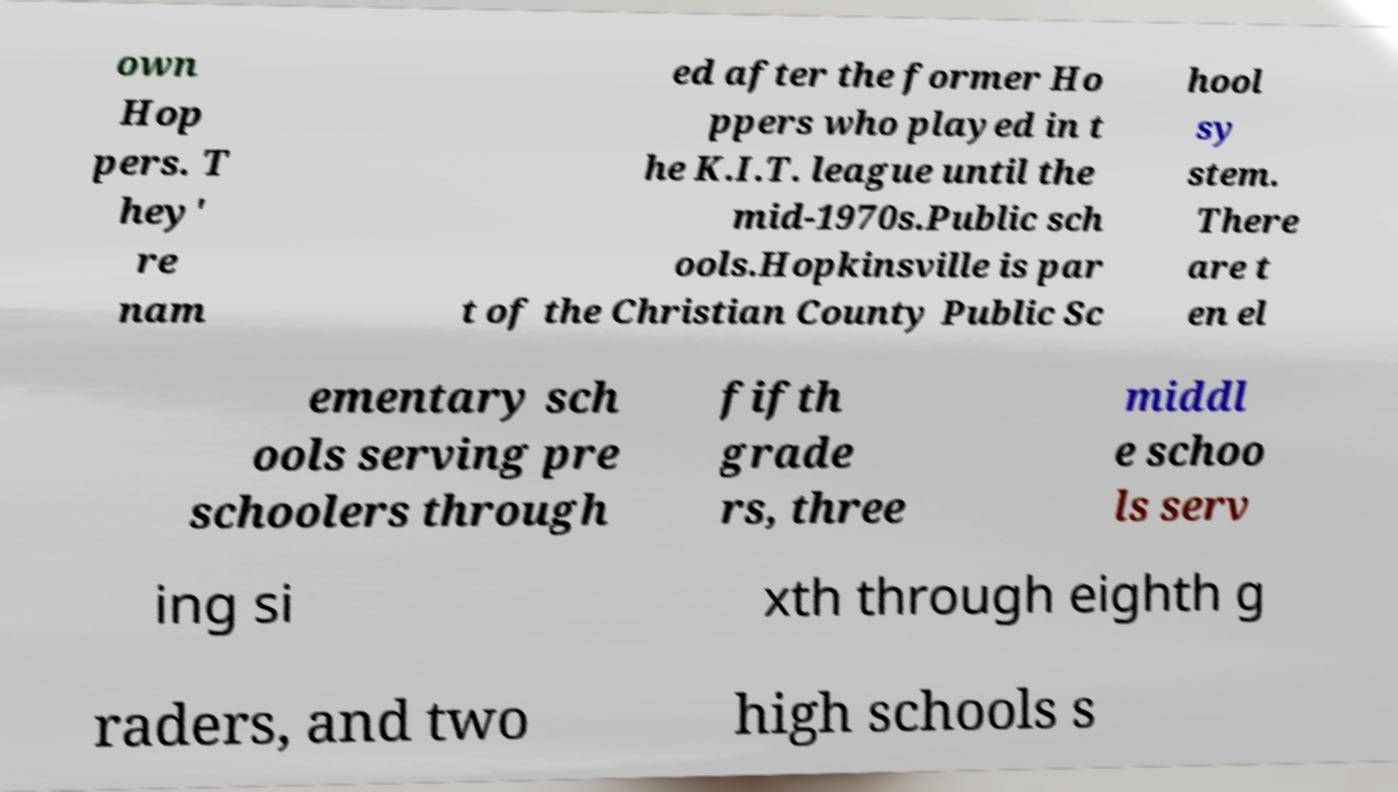Please read and relay the text visible in this image. What does it say? own Hop pers. T hey' re nam ed after the former Ho ppers who played in t he K.I.T. league until the mid-1970s.Public sch ools.Hopkinsville is par t of the Christian County Public Sc hool sy stem. There are t en el ementary sch ools serving pre schoolers through fifth grade rs, three middl e schoo ls serv ing si xth through eighth g raders, and two high schools s 